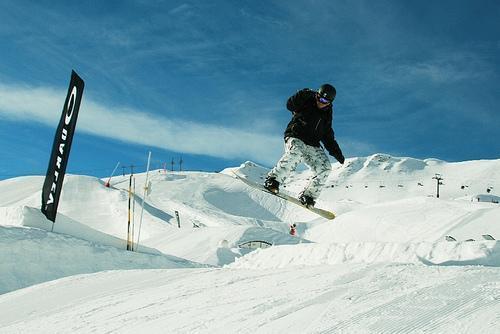How many people are there?
Give a very brief answer. 1. 